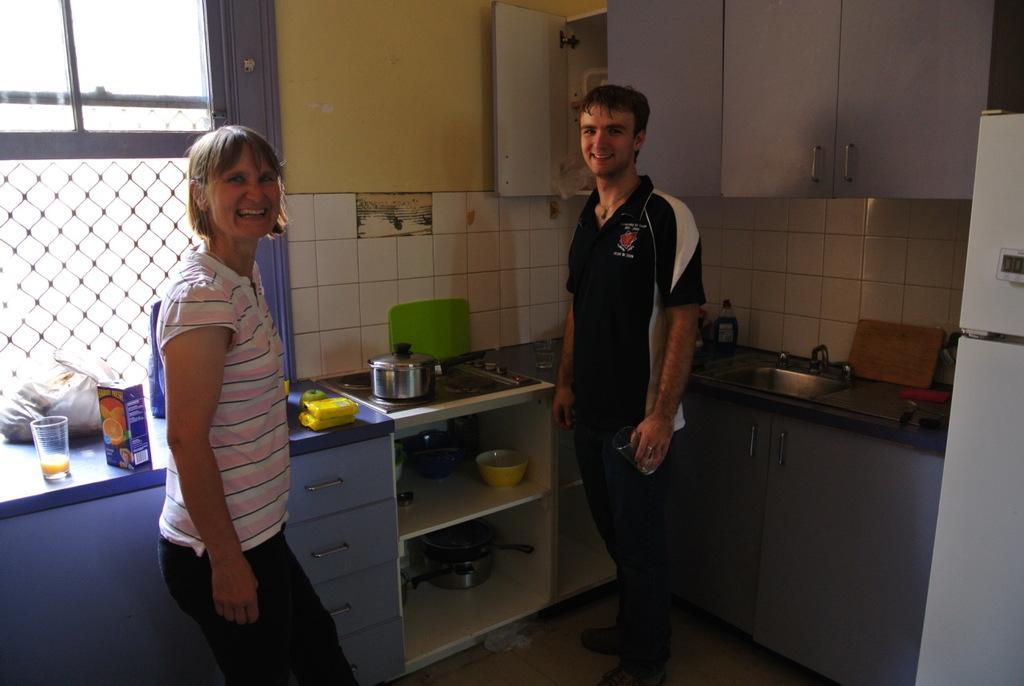How would you summarize this image in a sentence or two? There is a man standing on the right side and he is holding a glass in his hand and he is smiling. Here we can see a woman standing on the left side and she is smiling as well. Here we can see a bowl and this is a fruit glass. Here we can see a glass window which is on the left side. 